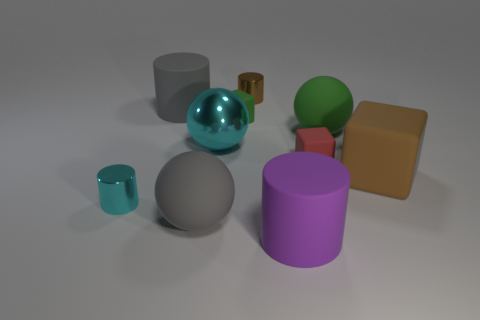Do the brown matte object and the red thing have the same size?
Your answer should be compact. No. What is the shape of the small metallic thing behind the tiny cyan metal thing that is in front of the brown thing behind the small red matte cube?
Your answer should be very brief. Cylinder. There is a rubber cylinder in front of the tiny green matte cube; does it have the same color as the metallic cylinder that is behind the small green matte thing?
Give a very brief answer. No. There is a purple object; are there any balls on the right side of it?
Keep it short and to the point. Yes. What number of other big brown rubber things have the same shape as the brown matte thing?
Make the answer very short. 0. The large ball that is to the right of the large cylinder to the right of the gray object behind the small red rubber block is what color?
Your answer should be very brief. Green. Do the large gray thing that is in front of the big gray rubber cylinder and the cyan object to the left of the gray cylinder have the same material?
Your answer should be very brief. No. How many objects are either matte balls to the left of the red matte thing or green matte balls?
Offer a terse response. 2. How many things are either big gray balls or rubber spheres that are in front of the brown cube?
Offer a terse response. 1. How many purple matte cylinders have the same size as the purple object?
Provide a succinct answer. 0. 